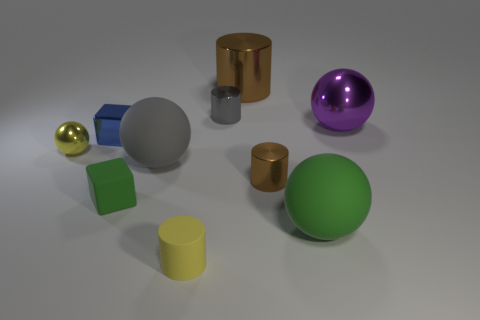The green object left of the tiny matte thing that is in front of the green thing to the left of the large green rubber sphere is made of what material?
Offer a very short reply. Rubber. Are there an equal number of gray rubber spheres that are behind the purple object and yellow metallic objects?
Provide a short and direct response. No. Is the brown thing behind the big purple metallic thing made of the same material as the cylinder that is in front of the green rubber ball?
Provide a short and direct response. No. Is there anything else that has the same material as the big gray thing?
Offer a terse response. Yes. There is a brown metal object in front of the blue cube; does it have the same shape as the matte thing on the right side of the yellow matte object?
Offer a terse response. No. Are there fewer brown metal cylinders that are right of the large brown cylinder than large red matte cylinders?
Provide a short and direct response. No. How many rubber spheres are the same color as the matte block?
Your answer should be very brief. 1. There is a block that is in front of the tiny yellow sphere; how big is it?
Make the answer very short. Small. What shape is the big rubber object to the right of the tiny metallic cylinder that is on the left side of the large metal object that is on the left side of the big green matte thing?
Offer a terse response. Sphere. What shape is the object that is both in front of the green matte block and behind the yellow cylinder?
Give a very brief answer. Sphere. 